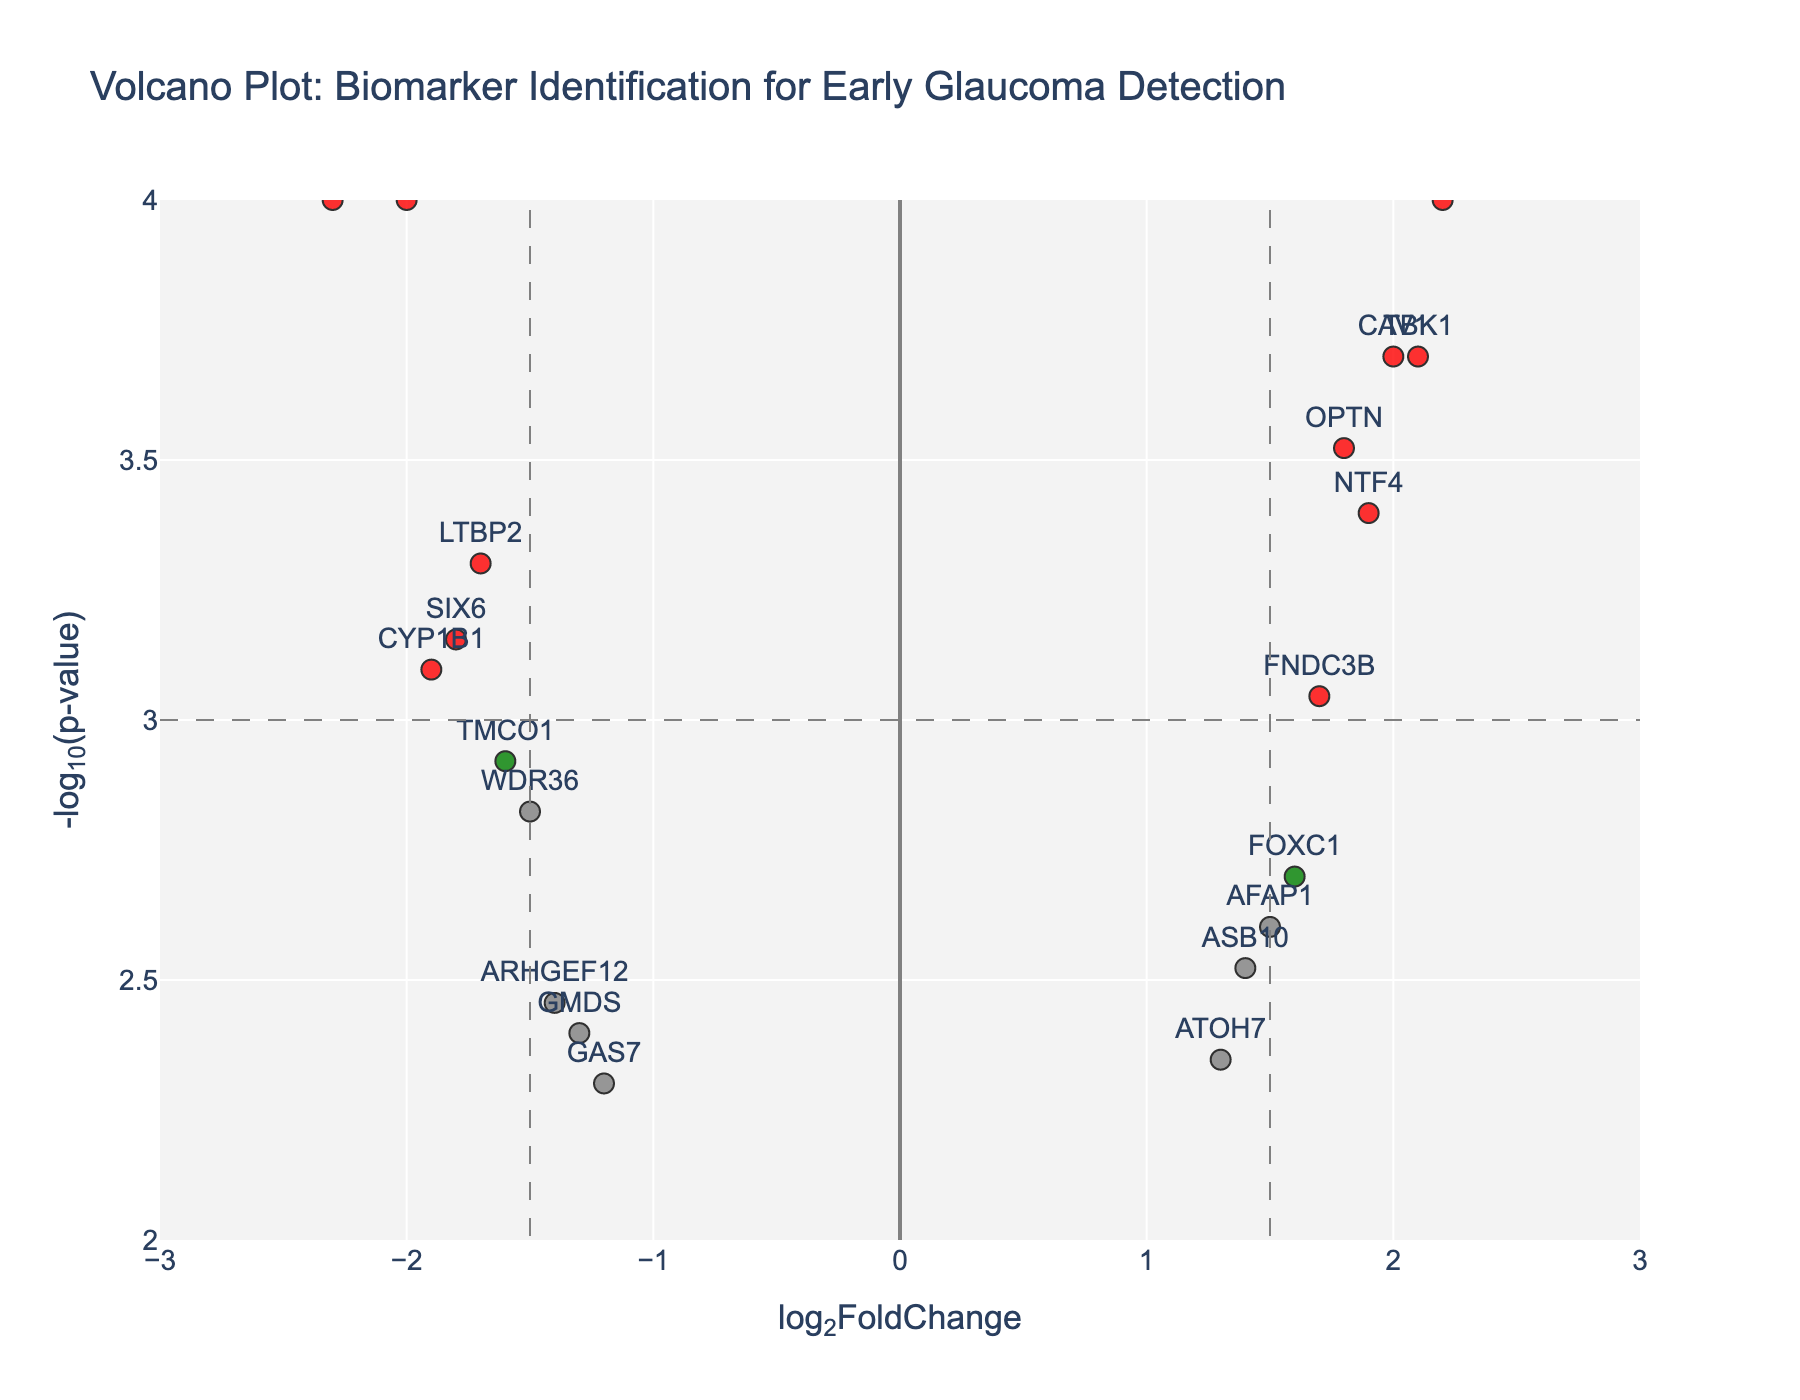Which gene has the highest -log10(p-value)? The -log10(p-value) is calculated from the p-value of the gene expression data. The gene with the highest -log10(p-value) is the most statistically significant. By the y-axis, CDKN2B, MYOC, and EFEMP1 all hit the highest mark.
Answer: CDKN2B, MYOC, and EFEMP1 What thresholds are used to highlight the significant genes? The plot uses both fold change and p-value thresholds. Genes with an absolute log2FoldChange greater than 1.5 and p-value below 0.001 are highlighted.
Answer: 1.5 (fold change) and 0.001 (p-value) How many genes are consistently marked in red? Genes marked in red meet both significance thresholds: log2FoldChange greater than 1.5 and p-value less than 0.001. Count the red-colored dots on the plot.
Answer: 9 genes Which gene has the lowest log2FoldChange and what is its significance level? By referring to the x-axis for log2FoldChange and looking for the most negative value, we identify the gene. Then, the y-axis provides the significance level.
Answer: MYOC, highly significant (p < 0.001) Which gene has the highest log2FoldChange? Is it significant? Referring to the rightmost point on the x-axis for log2FoldChange, observe the gene and verify if it is marked as significant (red).
Answer: CDKN2B, highly significant (p < 0.001) How many genes have a log2FoldChange value greater than 1.5? Count all data points to the right of the 1.5 log2FoldChange threshold line. This includes red and green dots.
Answer: 6 genes Which genes fall below the p-value threshold but with an absolute log2FoldChange below 1.5? Refer to the blue-marked dots, as they meet the p-value threshold but not the fold change threshold. Count each of these points.
Answer: 3 genes Between TBK1 and FOXC1, which gene is depicted as more statistically significant? Compare the y-axis values of both genes (higher -log10(p-value) signifies higher significance).
Answer: TBK1 Which genes have a log2FoldChange lower than -1.5 and are statistically significant? Look at the left side of the x-axis below -1.5 and ensure they also lie above the significance p-value threshold. Find these genes.
Answer: MYOC, WDR36, CYP1B1, LTBP2, EFEMP1, TMCO1, SIX6 